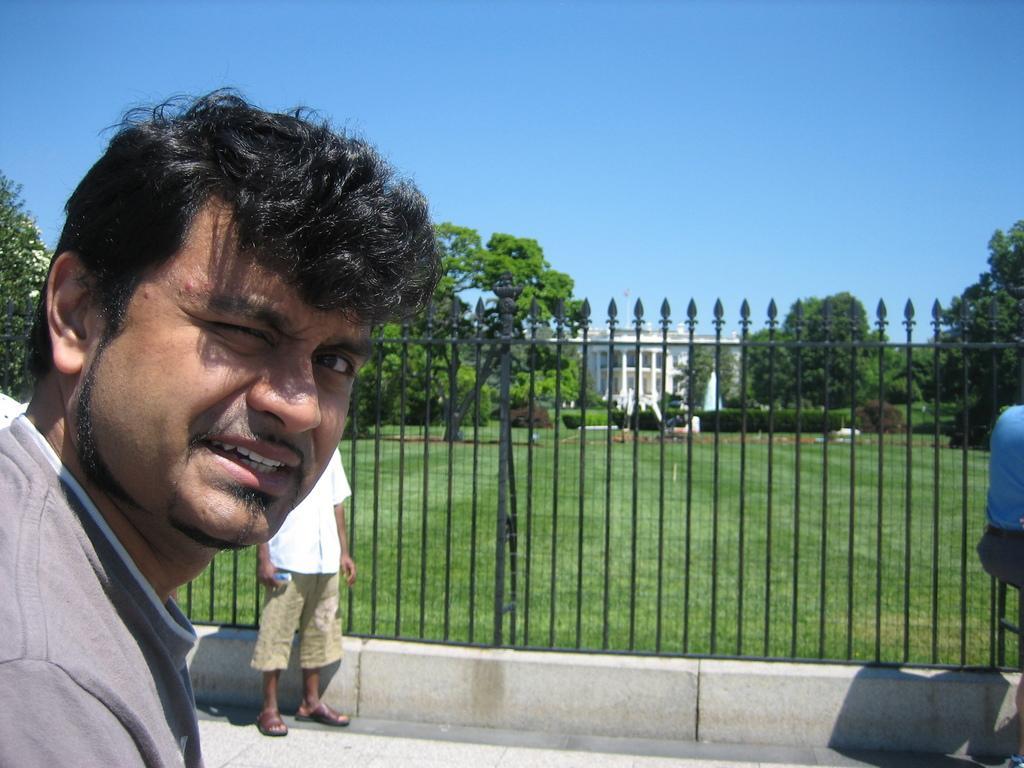In one or two sentences, can you explain what this image depicts? In this image we can see a person on the left side. In the back there is another person standing near to a railing. In the background there are trees and a building. On the ground there is grass. And there is sky. 